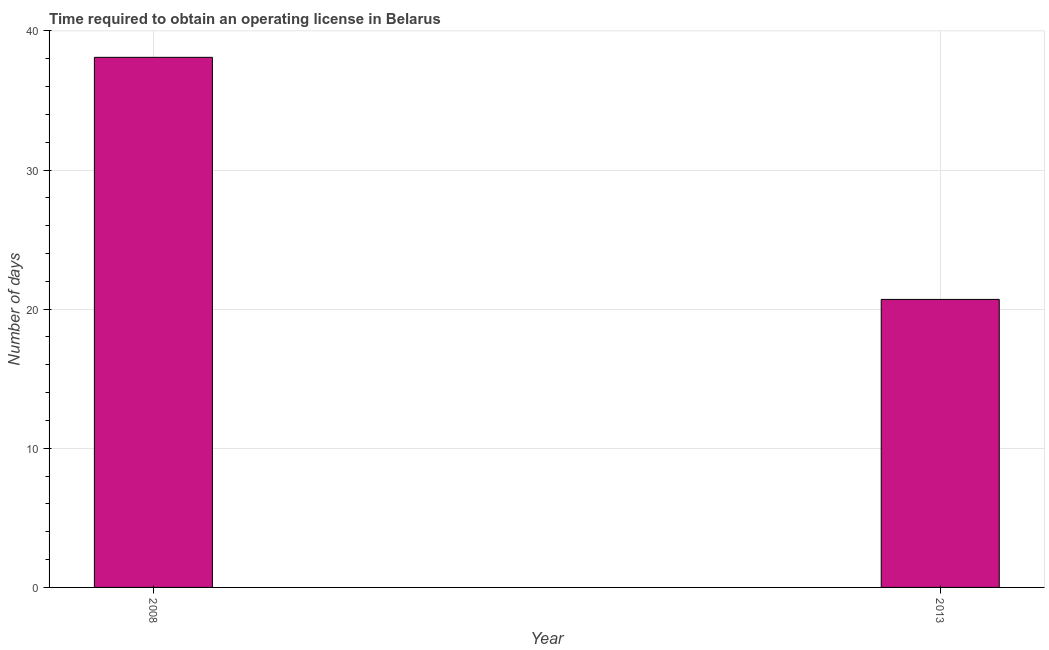Does the graph contain any zero values?
Your answer should be very brief. No. What is the title of the graph?
Your answer should be very brief. Time required to obtain an operating license in Belarus. What is the label or title of the X-axis?
Provide a short and direct response. Year. What is the label or title of the Y-axis?
Your answer should be very brief. Number of days. What is the number of days to obtain operating license in 2013?
Your response must be concise. 20.7. Across all years, what is the maximum number of days to obtain operating license?
Ensure brevity in your answer.  38.1. Across all years, what is the minimum number of days to obtain operating license?
Your answer should be very brief. 20.7. In which year was the number of days to obtain operating license minimum?
Offer a terse response. 2013. What is the sum of the number of days to obtain operating license?
Ensure brevity in your answer.  58.8. What is the average number of days to obtain operating license per year?
Keep it short and to the point. 29.4. What is the median number of days to obtain operating license?
Your answer should be very brief. 29.4. In how many years, is the number of days to obtain operating license greater than 12 days?
Ensure brevity in your answer.  2. Do a majority of the years between 2008 and 2013 (inclusive) have number of days to obtain operating license greater than 32 days?
Provide a succinct answer. No. What is the ratio of the number of days to obtain operating license in 2008 to that in 2013?
Offer a very short reply. 1.84. Is the number of days to obtain operating license in 2008 less than that in 2013?
Give a very brief answer. No. In how many years, is the number of days to obtain operating license greater than the average number of days to obtain operating license taken over all years?
Your answer should be compact. 1. How many years are there in the graph?
Make the answer very short. 2. What is the Number of days of 2008?
Ensure brevity in your answer.  38.1. What is the Number of days in 2013?
Make the answer very short. 20.7. What is the difference between the Number of days in 2008 and 2013?
Ensure brevity in your answer.  17.4. What is the ratio of the Number of days in 2008 to that in 2013?
Your answer should be very brief. 1.84. 